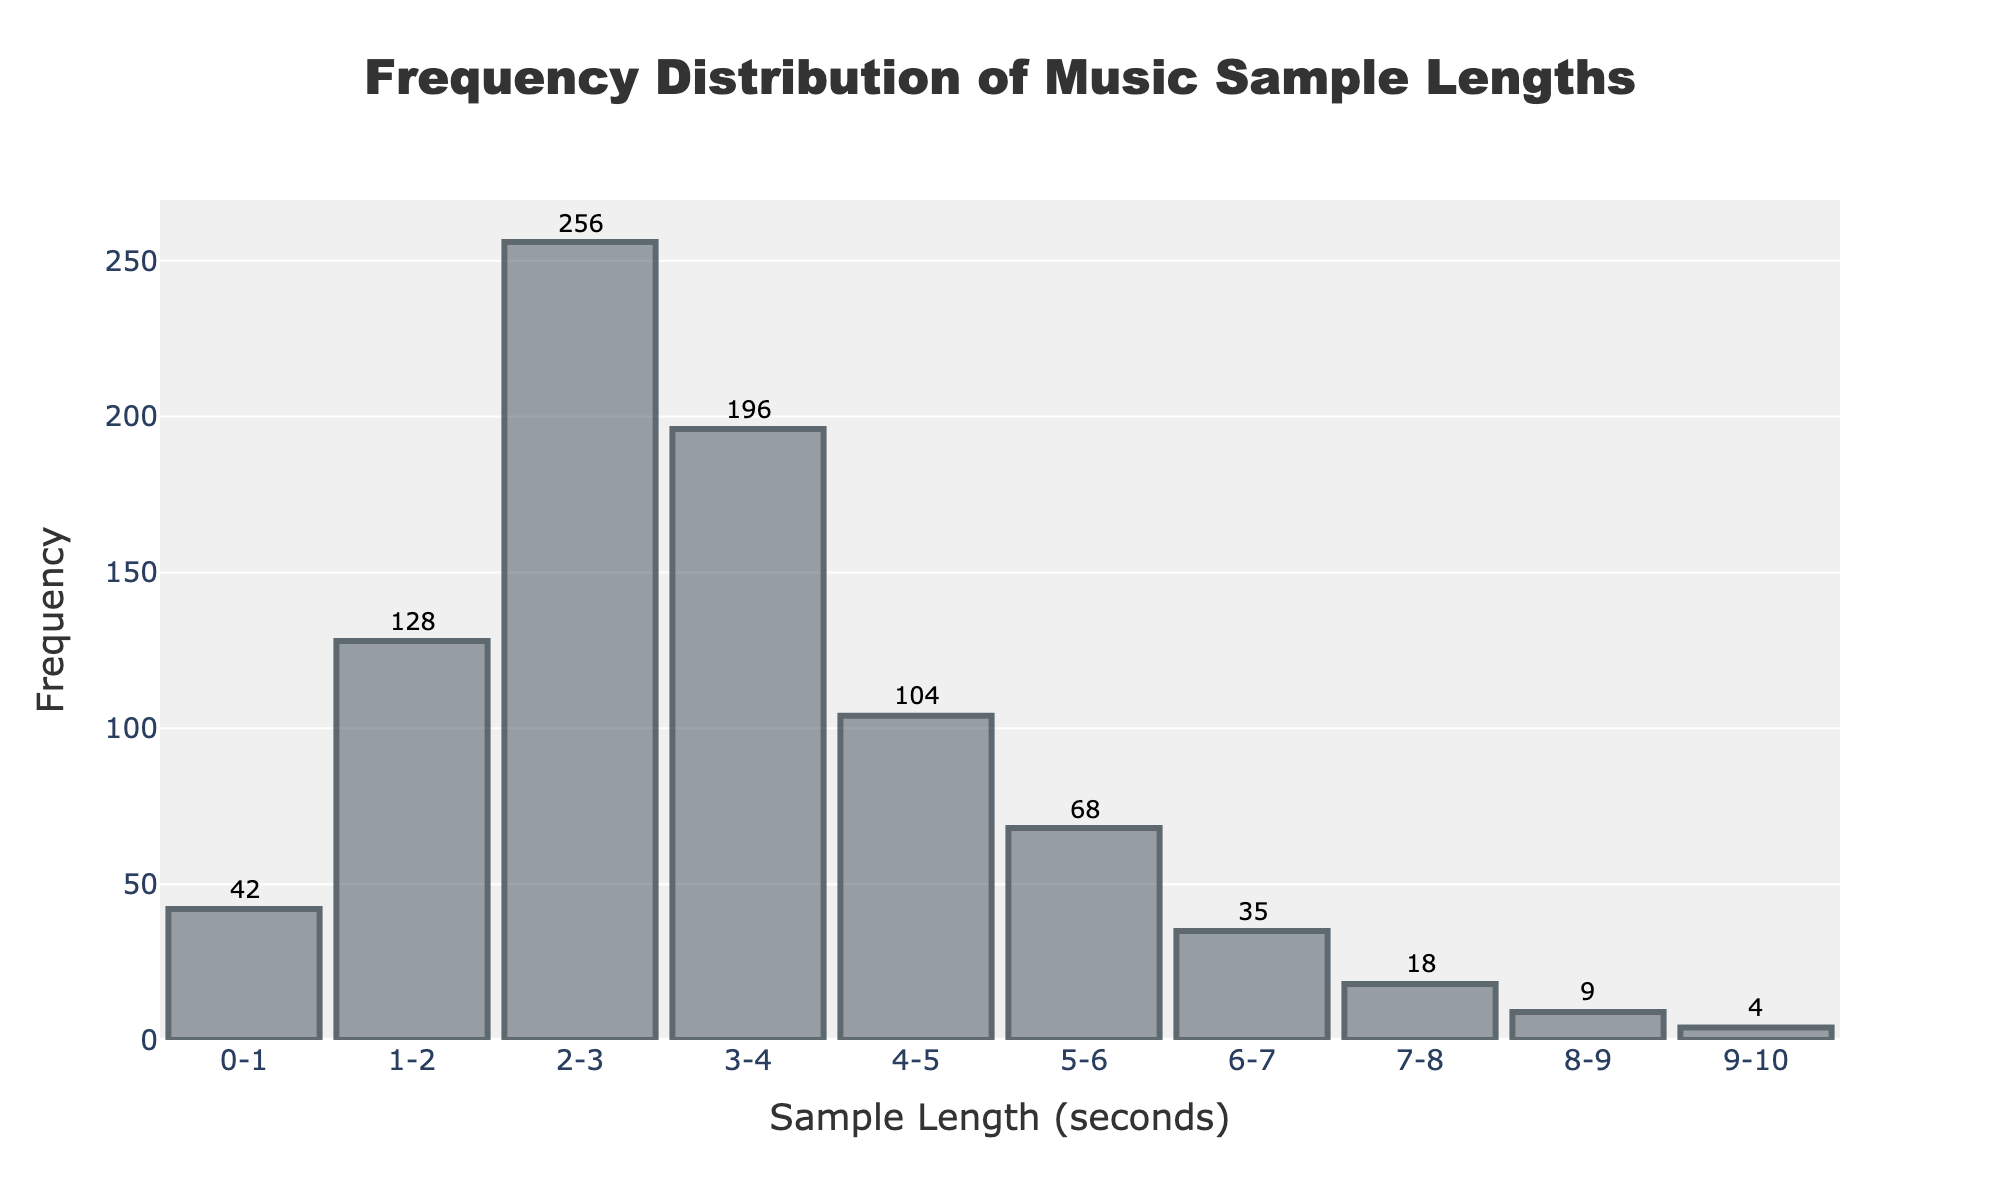What is the title of the figure? The title is displayed prominently at the top center of the figure. The provided title is "Frequency Distribution of Music Sample Lengths".
Answer: Frequency Distribution of Music Sample Lengths What is the frequency of music samples that are between 2 and 3 seconds long? The frequency for the sample length of 2-3 seconds is shown as a bar with a label. According to the data provided, it has a frequency of 256.
Answer: 256 Which sample length has the highest frequency? The highest bar on the histogram represents the sample length with the highest frequency. The bar for the 2-3 seconds range is the tallest, indicating this is the sample length with the most occurrences.
Answer: 2-3 seconds What is the sum of frequencies for sample lengths longer than 5 seconds? Add the frequencies for the bins from 5-6 seconds to 9-10 seconds: 68 + 35 + 18 + 9 + 4 = 134. Therefore, the sum of frequencies for these lengths is 134.
Answer: 134 How does the frequency of 5-6 second samples compare to those of 1-2 second samples? Compare the heights of the respective bars. The frequency for 5-6 seconds is 68, while for 1-2 seconds it is 128. Therefore, the 1-2 second samples occur more frequently.
Answer: 1-2 seconds are more frequent What is the range of sample lengths displayed on the x-axis? The x-axis displays sample lengths ranging from 0 seconds to 10 seconds, as indicated by the labels on the x-axis.
Answer: 0-10 seconds How many sample length groups have a frequency lower than 10? From the histogram, the bars for 9-10 seconds (4 samples) have visibility lower than 10. Adding these frequencies together confirms there are two groups (8-9 and 9-10 seconds) with frequencies below 10.
Answer: 2 groups What is the average frequency of samples that are less than 4 seconds long? First, sum the frequencies of the sample lengths from 0-1 to 3-4 seconds: 42 + 128 + 256 + 196 = 622. There are four groups, so to find the average frequency, divide by 4: 622 / 4 = 155.5.
Answer: 155.5 How does the frequency distribution appear overall? The histogram starts with relatively low frequencies for the shortest sample lengths, peaks at 2-3 seconds, and then gradually decreases as the sample length increases. This suggests a downward trend after the peak.
Answer: Peaks at 2-3s then declines Which sample length range has exactly half the frequency of the 3-4 second range? The frequency of the 3-4 second range is 196. Half of 196 is 98. The sample length range of 4-5 seconds has a frequency of 104, which is the closest to 98 but not exactly half. So there is no exact match, but 4-5 is the closest.
Answer: Closest is 4-5 seconds 